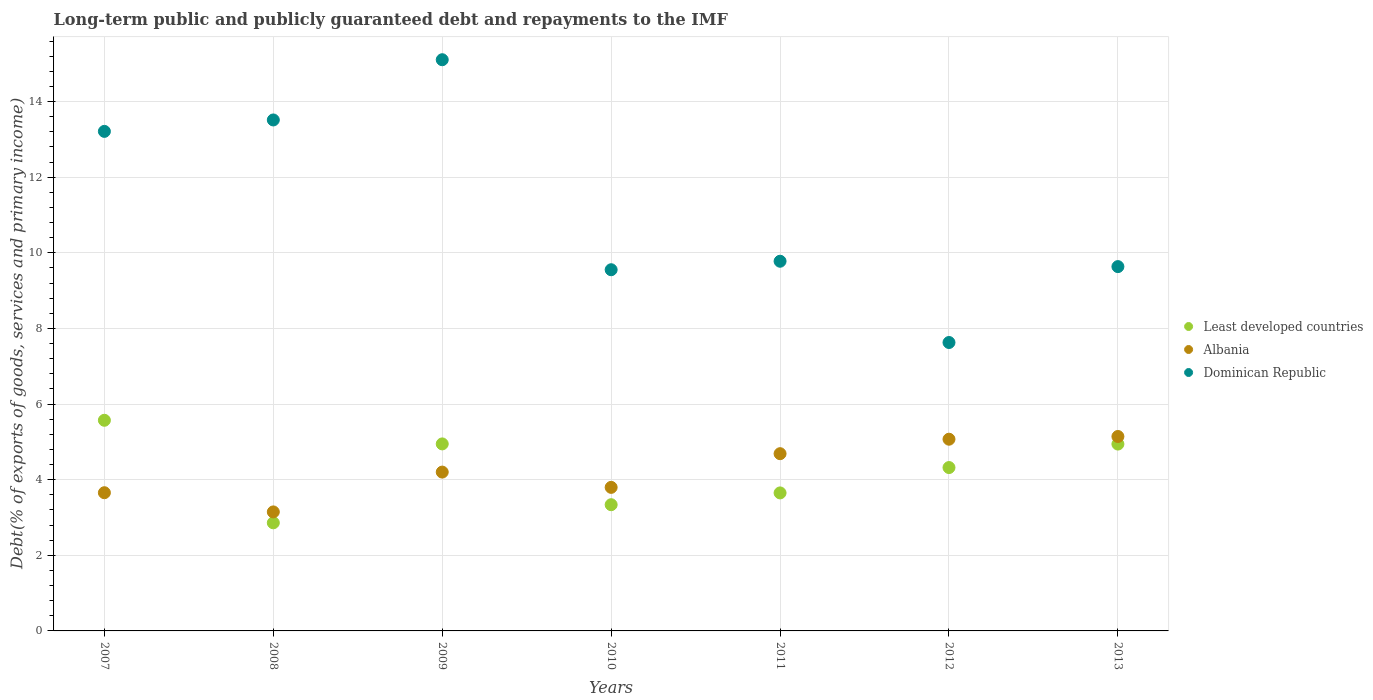How many different coloured dotlines are there?
Provide a succinct answer. 3. What is the debt and repayments in Albania in 2011?
Ensure brevity in your answer.  4.69. Across all years, what is the maximum debt and repayments in Least developed countries?
Make the answer very short. 5.57. Across all years, what is the minimum debt and repayments in Dominican Republic?
Offer a very short reply. 7.63. What is the total debt and repayments in Least developed countries in the graph?
Give a very brief answer. 29.63. What is the difference between the debt and repayments in Least developed countries in 2010 and that in 2012?
Your response must be concise. -0.98. What is the difference between the debt and repayments in Albania in 2011 and the debt and repayments in Dominican Republic in 2009?
Your answer should be very brief. -10.42. What is the average debt and repayments in Least developed countries per year?
Your answer should be compact. 4.23. In the year 2011, what is the difference between the debt and repayments in Least developed countries and debt and repayments in Albania?
Your answer should be very brief. -1.04. What is the ratio of the debt and repayments in Dominican Republic in 2007 to that in 2010?
Make the answer very short. 1.38. Is the debt and repayments in Least developed countries in 2010 less than that in 2013?
Provide a succinct answer. Yes. What is the difference between the highest and the second highest debt and repayments in Least developed countries?
Provide a succinct answer. 0.62. What is the difference between the highest and the lowest debt and repayments in Least developed countries?
Give a very brief answer. 2.71. In how many years, is the debt and repayments in Albania greater than the average debt and repayments in Albania taken over all years?
Ensure brevity in your answer.  3. Is it the case that in every year, the sum of the debt and repayments in Dominican Republic and debt and repayments in Least developed countries  is greater than the debt and repayments in Albania?
Provide a short and direct response. Yes. Does the debt and repayments in Albania monotonically increase over the years?
Offer a very short reply. No. Is the debt and repayments in Dominican Republic strictly less than the debt and repayments in Albania over the years?
Your answer should be compact. No. How many dotlines are there?
Keep it short and to the point. 3. Are the values on the major ticks of Y-axis written in scientific E-notation?
Offer a very short reply. No. Does the graph contain any zero values?
Make the answer very short. No. Does the graph contain grids?
Your answer should be compact. Yes. Where does the legend appear in the graph?
Offer a terse response. Center right. What is the title of the graph?
Ensure brevity in your answer.  Long-term public and publicly guaranteed debt and repayments to the IMF. What is the label or title of the X-axis?
Your response must be concise. Years. What is the label or title of the Y-axis?
Your answer should be very brief. Debt(% of exports of goods, services and primary income). What is the Debt(% of exports of goods, services and primary income) in Least developed countries in 2007?
Your answer should be compact. 5.57. What is the Debt(% of exports of goods, services and primary income) of Albania in 2007?
Your answer should be very brief. 3.66. What is the Debt(% of exports of goods, services and primary income) in Dominican Republic in 2007?
Keep it short and to the point. 13.21. What is the Debt(% of exports of goods, services and primary income) in Least developed countries in 2008?
Offer a terse response. 2.86. What is the Debt(% of exports of goods, services and primary income) in Albania in 2008?
Your response must be concise. 3.15. What is the Debt(% of exports of goods, services and primary income) in Dominican Republic in 2008?
Provide a short and direct response. 13.51. What is the Debt(% of exports of goods, services and primary income) in Least developed countries in 2009?
Provide a succinct answer. 4.95. What is the Debt(% of exports of goods, services and primary income) in Albania in 2009?
Provide a short and direct response. 4.2. What is the Debt(% of exports of goods, services and primary income) of Dominican Republic in 2009?
Provide a short and direct response. 15.11. What is the Debt(% of exports of goods, services and primary income) in Least developed countries in 2010?
Your answer should be compact. 3.34. What is the Debt(% of exports of goods, services and primary income) in Albania in 2010?
Your answer should be very brief. 3.8. What is the Debt(% of exports of goods, services and primary income) in Dominican Republic in 2010?
Provide a succinct answer. 9.55. What is the Debt(% of exports of goods, services and primary income) in Least developed countries in 2011?
Provide a succinct answer. 3.65. What is the Debt(% of exports of goods, services and primary income) in Albania in 2011?
Keep it short and to the point. 4.69. What is the Debt(% of exports of goods, services and primary income) in Dominican Republic in 2011?
Provide a short and direct response. 9.78. What is the Debt(% of exports of goods, services and primary income) of Least developed countries in 2012?
Your response must be concise. 4.32. What is the Debt(% of exports of goods, services and primary income) in Albania in 2012?
Make the answer very short. 5.07. What is the Debt(% of exports of goods, services and primary income) of Dominican Republic in 2012?
Give a very brief answer. 7.63. What is the Debt(% of exports of goods, services and primary income) of Least developed countries in 2013?
Provide a succinct answer. 4.94. What is the Debt(% of exports of goods, services and primary income) of Albania in 2013?
Your answer should be very brief. 5.14. What is the Debt(% of exports of goods, services and primary income) in Dominican Republic in 2013?
Ensure brevity in your answer.  9.64. Across all years, what is the maximum Debt(% of exports of goods, services and primary income) in Least developed countries?
Offer a very short reply. 5.57. Across all years, what is the maximum Debt(% of exports of goods, services and primary income) of Albania?
Keep it short and to the point. 5.14. Across all years, what is the maximum Debt(% of exports of goods, services and primary income) of Dominican Republic?
Ensure brevity in your answer.  15.11. Across all years, what is the minimum Debt(% of exports of goods, services and primary income) in Least developed countries?
Offer a very short reply. 2.86. Across all years, what is the minimum Debt(% of exports of goods, services and primary income) of Albania?
Give a very brief answer. 3.15. Across all years, what is the minimum Debt(% of exports of goods, services and primary income) in Dominican Republic?
Offer a terse response. 7.63. What is the total Debt(% of exports of goods, services and primary income) of Least developed countries in the graph?
Provide a succinct answer. 29.63. What is the total Debt(% of exports of goods, services and primary income) of Albania in the graph?
Ensure brevity in your answer.  29.7. What is the total Debt(% of exports of goods, services and primary income) in Dominican Republic in the graph?
Offer a very short reply. 78.42. What is the difference between the Debt(% of exports of goods, services and primary income) of Least developed countries in 2007 and that in 2008?
Provide a succinct answer. 2.71. What is the difference between the Debt(% of exports of goods, services and primary income) of Albania in 2007 and that in 2008?
Keep it short and to the point. 0.51. What is the difference between the Debt(% of exports of goods, services and primary income) of Dominican Republic in 2007 and that in 2008?
Give a very brief answer. -0.3. What is the difference between the Debt(% of exports of goods, services and primary income) in Least developed countries in 2007 and that in 2009?
Ensure brevity in your answer.  0.62. What is the difference between the Debt(% of exports of goods, services and primary income) of Albania in 2007 and that in 2009?
Provide a short and direct response. -0.55. What is the difference between the Debt(% of exports of goods, services and primary income) of Dominican Republic in 2007 and that in 2009?
Provide a succinct answer. -1.9. What is the difference between the Debt(% of exports of goods, services and primary income) in Least developed countries in 2007 and that in 2010?
Your answer should be very brief. 2.23. What is the difference between the Debt(% of exports of goods, services and primary income) in Albania in 2007 and that in 2010?
Provide a short and direct response. -0.14. What is the difference between the Debt(% of exports of goods, services and primary income) in Dominican Republic in 2007 and that in 2010?
Ensure brevity in your answer.  3.66. What is the difference between the Debt(% of exports of goods, services and primary income) of Least developed countries in 2007 and that in 2011?
Your response must be concise. 1.92. What is the difference between the Debt(% of exports of goods, services and primary income) in Albania in 2007 and that in 2011?
Ensure brevity in your answer.  -1.03. What is the difference between the Debt(% of exports of goods, services and primary income) of Dominican Republic in 2007 and that in 2011?
Your response must be concise. 3.43. What is the difference between the Debt(% of exports of goods, services and primary income) of Least developed countries in 2007 and that in 2012?
Your response must be concise. 1.25. What is the difference between the Debt(% of exports of goods, services and primary income) in Albania in 2007 and that in 2012?
Offer a very short reply. -1.42. What is the difference between the Debt(% of exports of goods, services and primary income) in Dominican Republic in 2007 and that in 2012?
Offer a very short reply. 5.58. What is the difference between the Debt(% of exports of goods, services and primary income) in Least developed countries in 2007 and that in 2013?
Your answer should be very brief. 0.63. What is the difference between the Debt(% of exports of goods, services and primary income) of Albania in 2007 and that in 2013?
Give a very brief answer. -1.49. What is the difference between the Debt(% of exports of goods, services and primary income) in Dominican Republic in 2007 and that in 2013?
Your response must be concise. 3.58. What is the difference between the Debt(% of exports of goods, services and primary income) in Least developed countries in 2008 and that in 2009?
Keep it short and to the point. -2.09. What is the difference between the Debt(% of exports of goods, services and primary income) in Albania in 2008 and that in 2009?
Give a very brief answer. -1.05. What is the difference between the Debt(% of exports of goods, services and primary income) of Dominican Republic in 2008 and that in 2009?
Provide a succinct answer. -1.59. What is the difference between the Debt(% of exports of goods, services and primary income) of Least developed countries in 2008 and that in 2010?
Offer a very short reply. -0.48. What is the difference between the Debt(% of exports of goods, services and primary income) of Albania in 2008 and that in 2010?
Give a very brief answer. -0.65. What is the difference between the Debt(% of exports of goods, services and primary income) in Dominican Republic in 2008 and that in 2010?
Offer a very short reply. 3.96. What is the difference between the Debt(% of exports of goods, services and primary income) in Least developed countries in 2008 and that in 2011?
Provide a short and direct response. -0.79. What is the difference between the Debt(% of exports of goods, services and primary income) of Albania in 2008 and that in 2011?
Ensure brevity in your answer.  -1.54. What is the difference between the Debt(% of exports of goods, services and primary income) in Dominican Republic in 2008 and that in 2011?
Your answer should be compact. 3.74. What is the difference between the Debt(% of exports of goods, services and primary income) in Least developed countries in 2008 and that in 2012?
Provide a succinct answer. -1.46. What is the difference between the Debt(% of exports of goods, services and primary income) in Albania in 2008 and that in 2012?
Give a very brief answer. -1.92. What is the difference between the Debt(% of exports of goods, services and primary income) in Dominican Republic in 2008 and that in 2012?
Offer a terse response. 5.89. What is the difference between the Debt(% of exports of goods, services and primary income) in Least developed countries in 2008 and that in 2013?
Offer a terse response. -2.08. What is the difference between the Debt(% of exports of goods, services and primary income) in Albania in 2008 and that in 2013?
Your response must be concise. -1.99. What is the difference between the Debt(% of exports of goods, services and primary income) of Dominican Republic in 2008 and that in 2013?
Offer a terse response. 3.88. What is the difference between the Debt(% of exports of goods, services and primary income) of Least developed countries in 2009 and that in 2010?
Make the answer very short. 1.61. What is the difference between the Debt(% of exports of goods, services and primary income) of Albania in 2009 and that in 2010?
Give a very brief answer. 0.4. What is the difference between the Debt(% of exports of goods, services and primary income) of Dominican Republic in 2009 and that in 2010?
Your response must be concise. 5.55. What is the difference between the Debt(% of exports of goods, services and primary income) of Least developed countries in 2009 and that in 2011?
Offer a terse response. 1.3. What is the difference between the Debt(% of exports of goods, services and primary income) in Albania in 2009 and that in 2011?
Give a very brief answer. -0.49. What is the difference between the Debt(% of exports of goods, services and primary income) in Dominican Republic in 2009 and that in 2011?
Provide a succinct answer. 5.33. What is the difference between the Debt(% of exports of goods, services and primary income) of Least developed countries in 2009 and that in 2012?
Offer a terse response. 0.63. What is the difference between the Debt(% of exports of goods, services and primary income) in Albania in 2009 and that in 2012?
Ensure brevity in your answer.  -0.87. What is the difference between the Debt(% of exports of goods, services and primary income) of Dominican Republic in 2009 and that in 2012?
Keep it short and to the point. 7.48. What is the difference between the Debt(% of exports of goods, services and primary income) of Least developed countries in 2009 and that in 2013?
Make the answer very short. 0. What is the difference between the Debt(% of exports of goods, services and primary income) of Albania in 2009 and that in 2013?
Your answer should be very brief. -0.94. What is the difference between the Debt(% of exports of goods, services and primary income) of Dominican Republic in 2009 and that in 2013?
Your answer should be very brief. 5.47. What is the difference between the Debt(% of exports of goods, services and primary income) in Least developed countries in 2010 and that in 2011?
Give a very brief answer. -0.31. What is the difference between the Debt(% of exports of goods, services and primary income) in Albania in 2010 and that in 2011?
Provide a short and direct response. -0.89. What is the difference between the Debt(% of exports of goods, services and primary income) in Dominican Republic in 2010 and that in 2011?
Keep it short and to the point. -0.22. What is the difference between the Debt(% of exports of goods, services and primary income) in Least developed countries in 2010 and that in 2012?
Provide a succinct answer. -0.98. What is the difference between the Debt(% of exports of goods, services and primary income) in Albania in 2010 and that in 2012?
Offer a terse response. -1.27. What is the difference between the Debt(% of exports of goods, services and primary income) in Dominican Republic in 2010 and that in 2012?
Your response must be concise. 1.92. What is the difference between the Debt(% of exports of goods, services and primary income) in Least developed countries in 2010 and that in 2013?
Offer a very short reply. -1.6. What is the difference between the Debt(% of exports of goods, services and primary income) of Albania in 2010 and that in 2013?
Your response must be concise. -1.35. What is the difference between the Debt(% of exports of goods, services and primary income) of Dominican Republic in 2010 and that in 2013?
Ensure brevity in your answer.  -0.08. What is the difference between the Debt(% of exports of goods, services and primary income) of Least developed countries in 2011 and that in 2012?
Make the answer very short. -0.67. What is the difference between the Debt(% of exports of goods, services and primary income) in Albania in 2011 and that in 2012?
Provide a short and direct response. -0.38. What is the difference between the Debt(% of exports of goods, services and primary income) in Dominican Republic in 2011 and that in 2012?
Your answer should be compact. 2.15. What is the difference between the Debt(% of exports of goods, services and primary income) of Least developed countries in 2011 and that in 2013?
Ensure brevity in your answer.  -1.29. What is the difference between the Debt(% of exports of goods, services and primary income) in Albania in 2011 and that in 2013?
Provide a succinct answer. -0.45. What is the difference between the Debt(% of exports of goods, services and primary income) in Dominican Republic in 2011 and that in 2013?
Offer a very short reply. 0.14. What is the difference between the Debt(% of exports of goods, services and primary income) of Least developed countries in 2012 and that in 2013?
Offer a very short reply. -0.62. What is the difference between the Debt(% of exports of goods, services and primary income) in Albania in 2012 and that in 2013?
Provide a succinct answer. -0.07. What is the difference between the Debt(% of exports of goods, services and primary income) of Dominican Republic in 2012 and that in 2013?
Your answer should be compact. -2.01. What is the difference between the Debt(% of exports of goods, services and primary income) in Least developed countries in 2007 and the Debt(% of exports of goods, services and primary income) in Albania in 2008?
Provide a succinct answer. 2.42. What is the difference between the Debt(% of exports of goods, services and primary income) of Least developed countries in 2007 and the Debt(% of exports of goods, services and primary income) of Dominican Republic in 2008?
Make the answer very short. -7.94. What is the difference between the Debt(% of exports of goods, services and primary income) of Albania in 2007 and the Debt(% of exports of goods, services and primary income) of Dominican Republic in 2008?
Your response must be concise. -9.86. What is the difference between the Debt(% of exports of goods, services and primary income) in Least developed countries in 2007 and the Debt(% of exports of goods, services and primary income) in Albania in 2009?
Provide a short and direct response. 1.37. What is the difference between the Debt(% of exports of goods, services and primary income) in Least developed countries in 2007 and the Debt(% of exports of goods, services and primary income) in Dominican Republic in 2009?
Keep it short and to the point. -9.54. What is the difference between the Debt(% of exports of goods, services and primary income) of Albania in 2007 and the Debt(% of exports of goods, services and primary income) of Dominican Republic in 2009?
Keep it short and to the point. -11.45. What is the difference between the Debt(% of exports of goods, services and primary income) of Least developed countries in 2007 and the Debt(% of exports of goods, services and primary income) of Albania in 2010?
Give a very brief answer. 1.77. What is the difference between the Debt(% of exports of goods, services and primary income) in Least developed countries in 2007 and the Debt(% of exports of goods, services and primary income) in Dominican Republic in 2010?
Your response must be concise. -3.98. What is the difference between the Debt(% of exports of goods, services and primary income) of Albania in 2007 and the Debt(% of exports of goods, services and primary income) of Dominican Republic in 2010?
Ensure brevity in your answer.  -5.9. What is the difference between the Debt(% of exports of goods, services and primary income) in Least developed countries in 2007 and the Debt(% of exports of goods, services and primary income) in Albania in 2011?
Provide a short and direct response. 0.88. What is the difference between the Debt(% of exports of goods, services and primary income) of Least developed countries in 2007 and the Debt(% of exports of goods, services and primary income) of Dominican Republic in 2011?
Make the answer very short. -4.21. What is the difference between the Debt(% of exports of goods, services and primary income) of Albania in 2007 and the Debt(% of exports of goods, services and primary income) of Dominican Republic in 2011?
Provide a succinct answer. -6.12. What is the difference between the Debt(% of exports of goods, services and primary income) in Least developed countries in 2007 and the Debt(% of exports of goods, services and primary income) in Albania in 2012?
Offer a very short reply. 0.5. What is the difference between the Debt(% of exports of goods, services and primary income) of Least developed countries in 2007 and the Debt(% of exports of goods, services and primary income) of Dominican Republic in 2012?
Provide a succinct answer. -2.06. What is the difference between the Debt(% of exports of goods, services and primary income) in Albania in 2007 and the Debt(% of exports of goods, services and primary income) in Dominican Republic in 2012?
Your answer should be very brief. -3.97. What is the difference between the Debt(% of exports of goods, services and primary income) of Least developed countries in 2007 and the Debt(% of exports of goods, services and primary income) of Albania in 2013?
Keep it short and to the point. 0.43. What is the difference between the Debt(% of exports of goods, services and primary income) of Least developed countries in 2007 and the Debt(% of exports of goods, services and primary income) of Dominican Republic in 2013?
Make the answer very short. -4.06. What is the difference between the Debt(% of exports of goods, services and primary income) of Albania in 2007 and the Debt(% of exports of goods, services and primary income) of Dominican Republic in 2013?
Offer a very short reply. -5.98. What is the difference between the Debt(% of exports of goods, services and primary income) in Least developed countries in 2008 and the Debt(% of exports of goods, services and primary income) in Albania in 2009?
Give a very brief answer. -1.34. What is the difference between the Debt(% of exports of goods, services and primary income) in Least developed countries in 2008 and the Debt(% of exports of goods, services and primary income) in Dominican Republic in 2009?
Your answer should be compact. -12.25. What is the difference between the Debt(% of exports of goods, services and primary income) of Albania in 2008 and the Debt(% of exports of goods, services and primary income) of Dominican Republic in 2009?
Offer a very short reply. -11.96. What is the difference between the Debt(% of exports of goods, services and primary income) in Least developed countries in 2008 and the Debt(% of exports of goods, services and primary income) in Albania in 2010?
Keep it short and to the point. -0.94. What is the difference between the Debt(% of exports of goods, services and primary income) in Least developed countries in 2008 and the Debt(% of exports of goods, services and primary income) in Dominican Republic in 2010?
Ensure brevity in your answer.  -6.69. What is the difference between the Debt(% of exports of goods, services and primary income) of Albania in 2008 and the Debt(% of exports of goods, services and primary income) of Dominican Republic in 2010?
Offer a terse response. -6.41. What is the difference between the Debt(% of exports of goods, services and primary income) of Least developed countries in 2008 and the Debt(% of exports of goods, services and primary income) of Albania in 2011?
Keep it short and to the point. -1.83. What is the difference between the Debt(% of exports of goods, services and primary income) of Least developed countries in 2008 and the Debt(% of exports of goods, services and primary income) of Dominican Republic in 2011?
Offer a very short reply. -6.92. What is the difference between the Debt(% of exports of goods, services and primary income) in Albania in 2008 and the Debt(% of exports of goods, services and primary income) in Dominican Republic in 2011?
Your response must be concise. -6.63. What is the difference between the Debt(% of exports of goods, services and primary income) in Least developed countries in 2008 and the Debt(% of exports of goods, services and primary income) in Albania in 2012?
Keep it short and to the point. -2.21. What is the difference between the Debt(% of exports of goods, services and primary income) of Least developed countries in 2008 and the Debt(% of exports of goods, services and primary income) of Dominican Republic in 2012?
Offer a terse response. -4.77. What is the difference between the Debt(% of exports of goods, services and primary income) in Albania in 2008 and the Debt(% of exports of goods, services and primary income) in Dominican Republic in 2012?
Your answer should be very brief. -4.48. What is the difference between the Debt(% of exports of goods, services and primary income) in Least developed countries in 2008 and the Debt(% of exports of goods, services and primary income) in Albania in 2013?
Make the answer very short. -2.28. What is the difference between the Debt(% of exports of goods, services and primary income) in Least developed countries in 2008 and the Debt(% of exports of goods, services and primary income) in Dominican Republic in 2013?
Your answer should be very brief. -6.78. What is the difference between the Debt(% of exports of goods, services and primary income) of Albania in 2008 and the Debt(% of exports of goods, services and primary income) of Dominican Republic in 2013?
Your response must be concise. -6.49. What is the difference between the Debt(% of exports of goods, services and primary income) in Least developed countries in 2009 and the Debt(% of exports of goods, services and primary income) in Albania in 2010?
Your response must be concise. 1.15. What is the difference between the Debt(% of exports of goods, services and primary income) in Least developed countries in 2009 and the Debt(% of exports of goods, services and primary income) in Dominican Republic in 2010?
Ensure brevity in your answer.  -4.61. What is the difference between the Debt(% of exports of goods, services and primary income) in Albania in 2009 and the Debt(% of exports of goods, services and primary income) in Dominican Republic in 2010?
Make the answer very short. -5.35. What is the difference between the Debt(% of exports of goods, services and primary income) in Least developed countries in 2009 and the Debt(% of exports of goods, services and primary income) in Albania in 2011?
Your answer should be compact. 0.26. What is the difference between the Debt(% of exports of goods, services and primary income) of Least developed countries in 2009 and the Debt(% of exports of goods, services and primary income) of Dominican Republic in 2011?
Your answer should be compact. -4.83. What is the difference between the Debt(% of exports of goods, services and primary income) in Albania in 2009 and the Debt(% of exports of goods, services and primary income) in Dominican Republic in 2011?
Provide a succinct answer. -5.58. What is the difference between the Debt(% of exports of goods, services and primary income) of Least developed countries in 2009 and the Debt(% of exports of goods, services and primary income) of Albania in 2012?
Your response must be concise. -0.12. What is the difference between the Debt(% of exports of goods, services and primary income) in Least developed countries in 2009 and the Debt(% of exports of goods, services and primary income) in Dominican Republic in 2012?
Give a very brief answer. -2.68. What is the difference between the Debt(% of exports of goods, services and primary income) in Albania in 2009 and the Debt(% of exports of goods, services and primary income) in Dominican Republic in 2012?
Offer a very short reply. -3.43. What is the difference between the Debt(% of exports of goods, services and primary income) of Least developed countries in 2009 and the Debt(% of exports of goods, services and primary income) of Albania in 2013?
Offer a very short reply. -0.2. What is the difference between the Debt(% of exports of goods, services and primary income) in Least developed countries in 2009 and the Debt(% of exports of goods, services and primary income) in Dominican Republic in 2013?
Provide a succinct answer. -4.69. What is the difference between the Debt(% of exports of goods, services and primary income) of Albania in 2009 and the Debt(% of exports of goods, services and primary income) of Dominican Republic in 2013?
Provide a short and direct response. -5.43. What is the difference between the Debt(% of exports of goods, services and primary income) of Least developed countries in 2010 and the Debt(% of exports of goods, services and primary income) of Albania in 2011?
Provide a succinct answer. -1.35. What is the difference between the Debt(% of exports of goods, services and primary income) in Least developed countries in 2010 and the Debt(% of exports of goods, services and primary income) in Dominican Republic in 2011?
Your response must be concise. -6.44. What is the difference between the Debt(% of exports of goods, services and primary income) of Albania in 2010 and the Debt(% of exports of goods, services and primary income) of Dominican Republic in 2011?
Your answer should be compact. -5.98. What is the difference between the Debt(% of exports of goods, services and primary income) in Least developed countries in 2010 and the Debt(% of exports of goods, services and primary income) in Albania in 2012?
Provide a succinct answer. -1.73. What is the difference between the Debt(% of exports of goods, services and primary income) in Least developed countries in 2010 and the Debt(% of exports of goods, services and primary income) in Dominican Republic in 2012?
Offer a terse response. -4.29. What is the difference between the Debt(% of exports of goods, services and primary income) in Albania in 2010 and the Debt(% of exports of goods, services and primary income) in Dominican Republic in 2012?
Keep it short and to the point. -3.83. What is the difference between the Debt(% of exports of goods, services and primary income) of Least developed countries in 2010 and the Debt(% of exports of goods, services and primary income) of Albania in 2013?
Your response must be concise. -1.8. What is the difference between the Debt(% of exports of goods, services and primary income) of Least developed countries in 2010 and the Debt(% of exports of goods, services and primary income) of Dominican Republic in 2013?
Ensure brevity in your answer.  -6.3. What is the difference between the Debt(% of exports of goods, services and primary income) in Albania in 2010 and the Debt(% of exports of goods, services and primary income) in Dominican Republic in 2013?
Provide a succinct answer. -5.84. What is the difference between the Debt(% of exports of goods, services and primary income) in Least developed countries in 2011 and the Debt(% of exports of goods, services and primary income) in Albania in 2012?
Make the answer very short. -1.42. What is the difference between the Debt(% of exports of goods, services and primary income) in Least developed countries in 2011 and the Debt(% of exports of goods, services and primary income) in Dominican Republic in 2012?
Your answer should be very brief. -3.98. What is the difference between the Debt(% of exports of goods, services and primary income) of Albania in 2011 and the Debt(% of exports of goods, services and primary income) of Dominican Republic in 2012?
Provide a succinct answer. -2.94. What is the difference between the Debt(% of exports of goods, services and primary income) of Least developed countries in 2011 and the Debt(% of exports of goods, services and primary income) of Albania in 2013?
Your response must be concise. -1.49. What is the difference between the Debt(% of exports of goods, services and primary income) of Least developed countries in 2011 and the Debt(% of exports of goods, services and primary income) of Dominican Republic in 2013?
Make the answer very short. -5.99. What is the difference between the Debt(% of exports of goods, services and primary income) in Albania in 2011 and the Debt(% of exports of goods, services and primary income) in Dominican Republic in 2013?
Provide a short and direct response. -4.95. What is the difference between the Debt(% of exports of goods, services and primary income) of Least developed countries in 2012 and the Debt(% of exports of goods, services and primary income) of Albania in 2013?
Make the answer very short. -0.82. What is the difference between the Debt(% of exports of goods, services and primary income) in Least developed countries in 2012 and the Debt(% of exports of goods, services and primary income) in Dominican Republic in 2013?
Ensure brevity in your answer.  -5.31. What is the difference between the Debt(% of exports of goods, services and primary income) of Albania in 2012 and the Debt(% of exports of goods, services and primary income) of Dominican Republic in 2013?
Provide a succinct answer. -4.56. What is the average Debt(% of exports of goods, services and primary income) of Least developed countries per year?
Keep it short and to the point. 4.23. What is the average Debt(% of exports of goods, services and primary income) of Albania per year?
Offer a very short reply. 4.24. What is the average Debt(% of exports of goods, services and primary income) of Dominican Republic per year?
Give a very brief answer. 11.2. In the year 2007, what is the difference between the Debt(% of exports of goods, services and primary income) in Least developed countries and Debt(% of exports of goods, services and primary income) in Albania?
Offer a very short reply. 1.92. In the year 2007, what is the difference between the Debt(% of exports of goods, services and primary income) of Least developed countries and Debt(% of exports of goods, services and primary income) of Dominican Republic?
Provide a short and direct response. -7.64. In the year 2007, what is the difference between the Debt(% of exports of goods, services and primary income) of Albania and Debt(% of exports of goods, services and primary income) of Dominican Republic?
Offer a very short reply. -9.56. In the year 2008, what is the difference between the Debt(% of exports of goods, services and primary income) of Least developed countries and Debt(% of exports of goods, services and primary income) of Albania?
Give a very brief answer. -0.29. In the year 2008, what is the difference between the Debt(% of exports of goods, services and primary income) of Least developed countries and Debt(% of exports of goods, services and primary income) of Dominican Republic?
Give a very brief answer. -10.65. In the year 2008, what is the difference between the Debt(% of exports of goods, services and primary income) in Albania and Debt(% of exports of goods, services and primary income) in Dominican Republic?
Provide a short and direct response. -10.37. In the year 2009, what is the difference between the Debt(% of exports of goods, services and primary income) of Least developed countries and Debt(% of exports of goods, services and primary income) of Albania?
Keep it short and to the point. 0.75. In the year 2009, what is the difference between the Debt(% of exports of goods, services and primary income) in Least developed countries and Debt(% of exports of goods, services and primary income) in Dominican Republic?
Your answer should be very brief. -10.16. In the year 2009, what is the difference between the Debt(% of exports of goods, services and primary income) of Albania and Debt(% of exports of goods, services and primary income) of Dominican Republic?
Provide a short and direct response. -10.91. In the year 2010, what is the difference between the Debt(% of exports of goods, services and primary income) of Least developed countries and Debt(% of exports of goods, services and primary income) of Albania?
Offer a terse response. -0.46. In the year 2010, what is the difference between the Debt(% of exports of goods, services and primary income) in Least developed countries and Debt(% of exports of goods, services and primary income) in Dominican Republic?
Your response must be concise. -6.21. In the year 2010, what is the difference between the Debt(% of exports of goods, services and primary income) in Albania and Debt(% of exports of goods, services and primary income) in Dominican Republic?
Give a very brief answer. -5.76. In the year 2011, what is the difference between the Debt(% of exports of goods, services and primary income) in Least developed countries and Debt(% of exports of goods, services and primary income) in Albania?
Ensure brevity in your answer.  -1.04. In the year 2011, what is the difference between the Debt(% of exports of goods, services and primary income) in Least developed countries and Debt(% of exports of goods, services and primary income) in Dominican Republic?
Offer a very short reply. -6.13. In the year 2011, what is the difference between the Debt(% of exports of goods, services and primary income) of Albania and Debt(% of exports of goods, services and primary income) of Dominican Republic?
Make the answer very short. -5.09. In the year 2012, what is the difference between the Debt(% of exports of goods, services and primary income) of Least developed countries and Debt(% of exports of goods, services and primary income) of Albania?
Your response must be concise. -0.75. In the year 2012, what is the difference between the Debt(% of exports of goods, services and primary income) of Least developed countries and Debt(% of exports of goods, services and primary income) of Dominican Republic?
Ensure brevity in your answer.  -3.31. In the year 2012, what is the difference between the Debt(% of exports of goods, services and primary income) of Albania and Debt(% of exports of goods, services and primary income) of Dominican Republic?
Keep it short and to the point. -2.56. In the year 2013, what is the difference between the Debt(% of exports of goods, services and primary income) in Least developed countries and Debt(% of exports of goods, services and primary income) in Albania?
Your answer should be compact. -0.2. In the year 2013, what is the difference between the Debt(% of exports of goods, services and primary income) of Least developed countries and Debt(% of exports of goods, services and primary income) of Dominican Republic?
Your answer should be very brief. -4.69. In the year 2013, what is the difference between the Debt(% of exports of goods, services and primary income) of Albania and Debt(% of exports of goods, services and primary income) of Dominican Republic?
Make the answer very short. -4.49. What is the ratio of the Debt(% of exports of goods, services and primary income) of Least developed countries in 2007 to that in 2008?
Provide a succinct answer. 1.95. What is the ratio of the Debt(% of exports of goods, services and primary income) in Albania in 2007 to that in 2008?
Provide a succinct answer. 1.16. What is the ratio of the Debt(% of exports of goods, services and primary income) of Dominican Republic in 2007 to that in 2008?
Your answer should be compact. 0.98. What is the ratio of the Debt(% of exports of goods, services and primary income) of Least developed countries in 2007 to that in 2009?
Make the answer very short. 1.13. What is the ratio of the Debt(% of exports of goods, services and primary income) in Albania in 2007 to that in 2009?
Ensure brevity in your answer.  0.87. What is the ratio of the Debt(% of exports of goods, services and primary income) of Dominican Republic in 2007 to that in 2009?
Make the answer very short. 0.87. What is the ratio of the Debt(% of exports of goods, services and primary income) in Least developed countries in 2007 to that in 2010?
Keep it short and to the point. 1.67. What is the ratio of the Debt(% of exports of goods, services and primary income) of Albania in 2007 to that in 2010?
Your response must be concise. 0.96. What is the ratio of the Debt(% of exports of goods, services and primary income) in Dominican Republic in 2007 to that in 2010?
Your response must be concise. 1.38. What is the ratio of the Debt(% of exports of goods, services and primary income) of Least developed countries in 2007 to that in 2011?
Your answer should be very brief. 1.53. What is the ratio of the Debt(% of exports of goods, services and primary income) in Albania in 2007 to that in 2011?
Provide a short and direct response. 0.78. What is the ratio of the Debt(% of exports of goods, services and primary income) in Dominican Republic in 2007 to that in 2011?
Ensure brevity in your answer.  1.35. What is the ratio of the Debt(% of exports of goods, services and primary income) in Least developed countries in 2007 to that in 2012?
Make the answer very short. 1.29. What is the ratio of the Debt(% of exports of goods, services and primary income) of Albania in 2007 to that in 2012?
Give a very brief answer. 0.72. What is the ratio of the Debt(% of exports of goods, services and primary income) in Dominican Republic in 2007 to that in 2012?
Provide a succinct answer. 1.73. What is the ratio of the Debt(% of exports of goods, services and primary income) in Least developed countries in 2007 to that in 2013?
Your answer should be compact. 1.13. What is the ratio of the Debt(% of exports of goods, services and primary income) in Albania in 2007 to that in 2013?
Ensure brevity in your answer.  0.71. What is the ratio of the Debt(% of exports of goods, services and primary income) of Dominican Republic in 2007 to that in 2013?
Keep it short and to the point. 1.37. What is the ratio of the Debt(% of exports of goods, services and primary income) of Least developed countries in 2008 to that in 2009?
Your response must be concise. 0.58. What is the ratio of the Debt(% of exports of goods, services and primary income) of Albania in 2008 to that in 2009?
Offer a very short reply. 0.75. What is the ratio of the Debt(% of exports of goods, services and primary income) in Dominican Republic in 2008 to that in 2009?
Ensure brevity in your answer.  0.89. What is the ratio of the Debt(% of exports of goods, services and primary income) in Least developed countries in 2008 to that in 2010?
Provide a succinct answer. 0.86. What is the ratio of the Debt(% of exports of goods, services and primary income) of Albania in 2008 to that in 2010?
Offer a very short reply. 0.83. What is the ratio of the Debt(% of exports of goods, services and primary income) of Dominican Republic in 2008 to that in 2010?
Ensure brevity in your answer.  1.41. What is the ratio of the Debt(% of exports of goods, services and primary income) of Least developed countries in 2008 to that in 2011?
Ensure brevity in your answer.  0.78. What is the ratio of the Debt(% of exports of goods, services and primary income) of Albania in 2008 to that in 2011?
Provide a succinct answer. 0.67. What is the ratio of the Debt(% of exports of goods, services and primary income) of Dominican Republic in 2008 to that in 2011?
Your response must be concise. 1.38. What is the ratio of the Debt(% of exports of goods, services and primary income) in Least developed countries in 2008 to that in 2012?
Your answer should be compact. 0.66. What is the ratio of the Debt(% of exports of goods, services and primary income) in Albania in 2008 to that in 2012?
Your answer should be very brief. 0.62. What is the ratio of the Debt(% of exports of goods, services and primary income) in Dominican Republic in 2008 to that in 2012?
Give a very brief answer. 1.77. What is the ratio of the Debt(% of exports of goods, services and primary income) of Least developed countries in 2008 to that in 2013?
Your answer should be very brief. 0.58. What is the ratio of the Debt(% of exports of goods, services and primary income) of Albania in 2008 to that in 2013?
Ensure brevity in your answer.  0.61. What is the ratio of the Debt(% of exports of goods, services and primary income) in Dominican Republic in 2008 to that in 2013?
Your answer should be compact. 1.4. What is the ratio of the Debt(% of exports of goods, services and primary income) in Least developed countries in 2009 to that in 2010?
Give a very brief answer. 1.48. What is the ratio of the Debt(% of exports of goods, services and primary income) of Albania in 2009 to that in 2010?
Provide a short and direct response. 1.11. What is the ratio of the Debt(% of exports of goods, services and primary income) of Dominican Republic in 2009 to that in 2010?
Your response must be concise. 1.58. What is the ratio of the Debt(% of exports of goods, services and primary income) of Least developed countries in 2009 to that in 2011?
Your response must be concise. 1.36. What is the ratio of the Debt(% of exports of goods, services and primary income) of Albania in 2009 to that in 2011?
Ensure brevity in your answer.  0.9. What is the ratio of the Debt(% of exports of goods, services and primary income) in Dominican Republic in 2009 to that in 2011?
Ensure brevity in your answer.  1.55. What is the ratio of the Debt(% of exports of goods, services and primary income) in Least developed countries in 2009 to that in 2012?
Your answer should be compact. 1.14. What is the ratio of the Debt(% of exports of goods, services and primary income) in Albania in 2009 to that in 2012?
Your response must be concise. 0.83. What is the ratio of the Debt(% of exports of goods, services and primary income) of Dominican Republic in 2009 to that in 2012?
Your response must be concise. 1.98. What is the ratio of the Debt(% of exports of goods, services and primary income) of Albania in 2009 to that in 2013?
Keep it short and to the point. 0.82. What is the ratio of the Debt(% of exports of goods, services and primary income) of Dominican Republic in 2009 to that in 2013?
Your answer should be very brief. 1.57. What is the ratio of the Debt(% of exports of goods, services and primary income) of Least developed countries in 2010 to that in 2011?
Your response must be concise. 0.91. What is the ratio of the Debt(% of exports of goods, services and primary income) of Albania in 2010 to that in 2011?
Provide a short and direct response. 0.81. What is the ratio of the Debt(% of exports of goods, services and primary income) of Dominican Republic in 2010 to that in 2011?
Your answer should be very brief. 0.98. What is the ratio of the Debt(% of exports of goods, services and primary income) in Least developed countries in 2010 to that in 2012?
Your answer should be very brief. 0.77. What is the ratio of the Debt(% of exports of goods, services and primary income) in Albania in 2010 to that in 2012?
Ensure brevity in your answer.  0.75. What is the ratio of the Debt(% of exports of goods, services and primary income) in Dominican Republic in 2010 to that in 2012?
Make the answer very short. 1.25. What is the ratio of the Debt(% of exports of goods, services and primary income) of Least developed countries in 2010 to that in 2013?
Make the answer very short. 0.68. What is the ratio of the Debt(% of exports of goods, services and primary income) in Albania in 2010 to that in 2013?
Provide a succinct answer. 0.74. What is the ratio of the Debt(% of exports of goods, services and primary income) in Least developed countries in 2011 to that in 2012?
Ensure brevity in your answer.  0.84. What is the ratio of the Debt(% of exports of goods, services and primary income) of Albania in 2011 to that in 2012?
Offer a terse response. 0.92. What is the ratio of the Debt(% of exports of goods, services and primary income) in Dominican Republic in 2011 to that in 2012?
Offer a terse response. 1.28. What is the ratio of the Debt(% of exports of goods, services and primary income) in Least developed countries in 2011 to that in 2013?
Offer a terse response. 0.74. What is the ratio of the Debt(% of exports of goods, services and primary income) of Albania in 2011 to that in 2013?
Give a very brief answer. 0.91. What is the ratio of the Debt(% of exports of goods, services and primary income) of Dominican Republic in 2011 to that in 2013?
Offer a terse response. 1.01. What is the ratio of the Debt(% of exports of goods, services and primary income) in Least developed countries in 2012 to that in 2013?
Your answer should be very brief. 0.87. What is the ratio of the Debt(% of exports of goods, services and primary income) of Dominican Republic in 2012 to that in 2013?
Offer a terse response. 0.79. What is the difference between the highest and the second highest Debt(% of exports of goods, services and primary income) in Least developed countries?
Your answer should be very brief. 0.62. What is the difference between the highest and the second highest Debt(% of exports of goods, services and primary income) of Albania?
Your answer should be compact. 0.07. What is the difference between the highest and the second highest Debt(% of exports of goods, services and primary income) in Dominican Republic?
Offer a very short reply. 1.59. What is the difference between the highest and the lowest Debt(% of exports of goods, services and primary income) of Least developed countries?
Offer a very short reply. 2.71. What is the difference between the highest and the lowest Debt(% of exports of goods, services and primary income) of Albania?
Offer a terse response. 1.99. What is the difference between the highest and the lowest Debt(% of exports of goods, services and primary income) of Dominican Republic?
Ensure brevity in your answer.  7.48. 